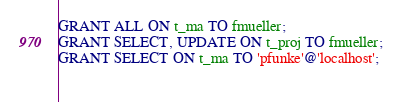<code> <loc_0><loc_0><loc_500><loc_500><_SQL_>GRANT ALL ON t_ma TO fmueller;
GRANT SELECT, UPDATE ON t_proj TO fmueller;
GRANT SELECT ON t_ma TO 'pfunke'@'localhost';
 </code> 